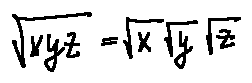Convert formula to latex. <formula><loc_0><loc_0><loc_500><loc_500>\sqrt { x y z } = \sqrt { x } \sqrt { y } \sqrt { z }</formula> 